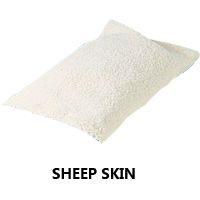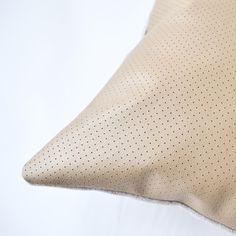The first image is the image on the left, the second image is the image on the right. For the images shown, is this caption "The left image contains a single item." true? Answer yes or no. Yes. 